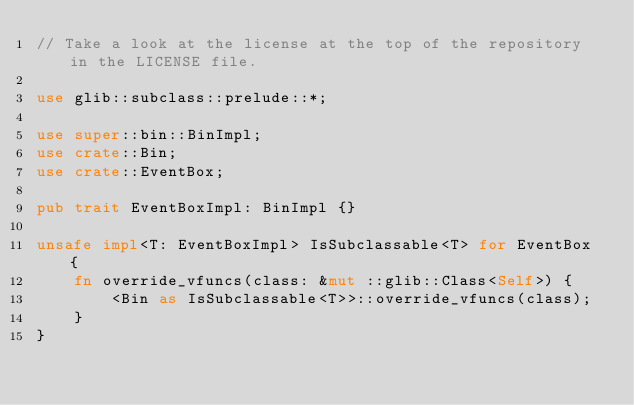<code> <loc_0><loc_0><loc_500><loc_500><_Rust_>// Take a look at the license at the top of the repository in the LICENSE file.

use glib::subclass::prelude::*;

use super::bin::BinImpl;
use crate::Bin;
use crate::EventBox;

pub trait EventBoxImpl: BinImpl {}

unsafe impl<T: EventBoxImpl> IsSubclassable<T> for EventBox {
    fn override_vfuncs(class: &mut ::glib::Class<Self>) {
        <Bin as IsSubclassable<T>>::override_vfuncs(class);
    }
}
</code> 